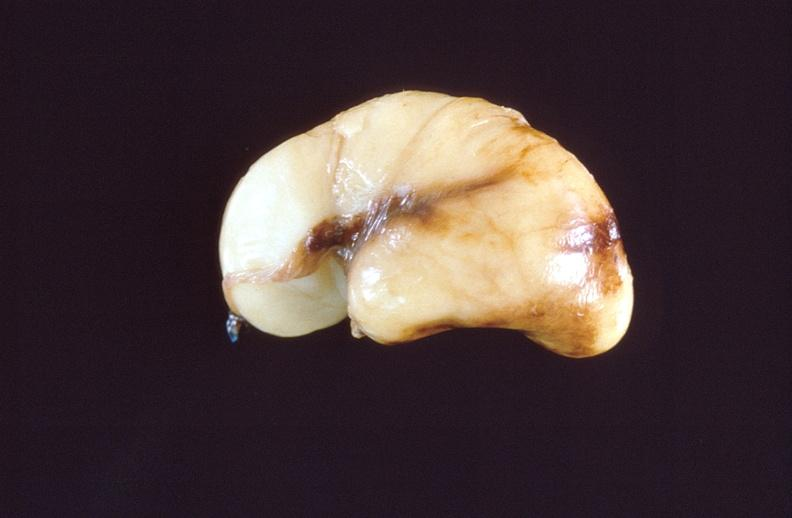s retroperitoneum present?
Answer the question using a single word or phrase. No 